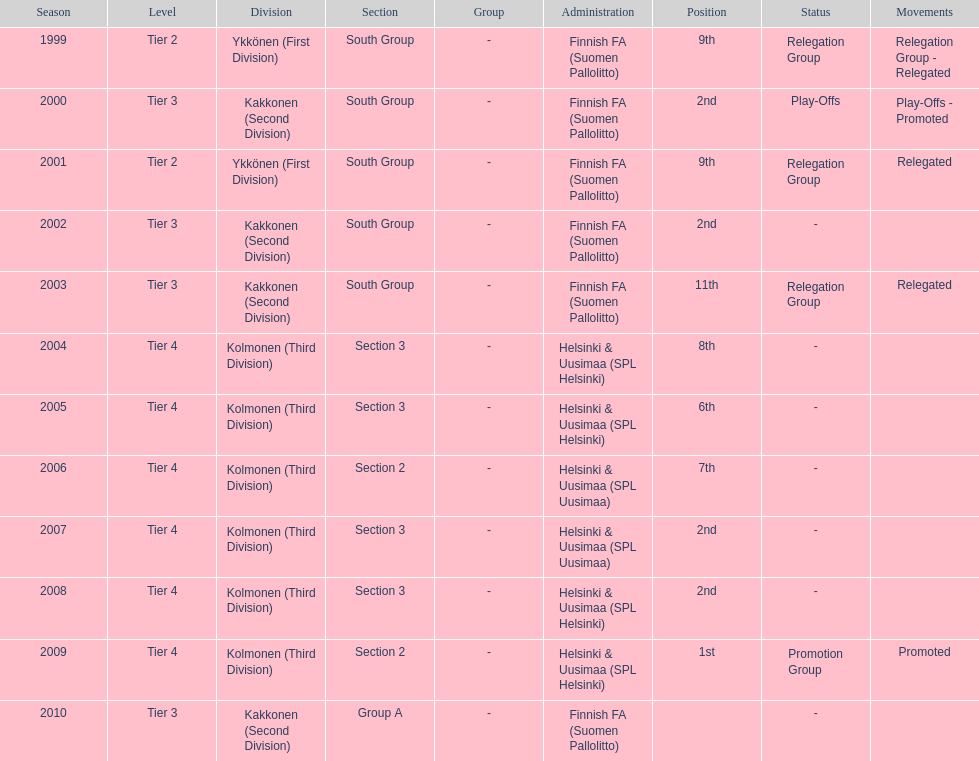When was the last year they placed 2nd? 2008. 